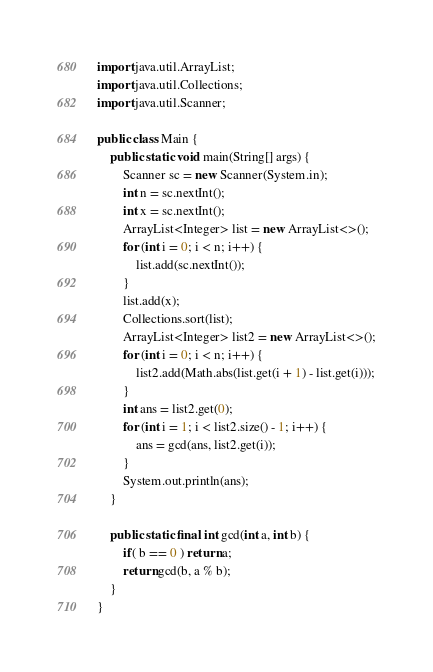Convert code to text. <code><loc_0><loc_0><loc_500><loc_500><_Java_>import java.util.ArrayList;
import java.util.Collections;
import java.util.Scanner;

public class Main {
    public static void main(String[] args) {
        Scanner sc = new Scanner(System.in);
        int n = sc.nextInt();
        int x = sc.nextInt();
        ArrayList<Integer> list = new ArrayList<>();
        for (int i = 0; i < n; i++) {
            list.add(sc.nextInt());
        }
        list.add(x);
        Collections.sort(list);
        ArrayList<Integer> list2 = new ArrayList<>();
        for (int i = 0; i < n; i++) {
            list2.add(Math.abs(list.get(i + 1) - list.get(i)));
        }
        int ans = list2.get(0);
        for (int i = 1; i < list2.size() - 1; i++) {
            ans = gcd(ans, list2.get(i));
        }
        System.out.println(ans);
    }

    public static final int gcd(int a, int b) {
        if( b == 0 ) return a;
        return gcd(b, a % b);
    }
}</code> 